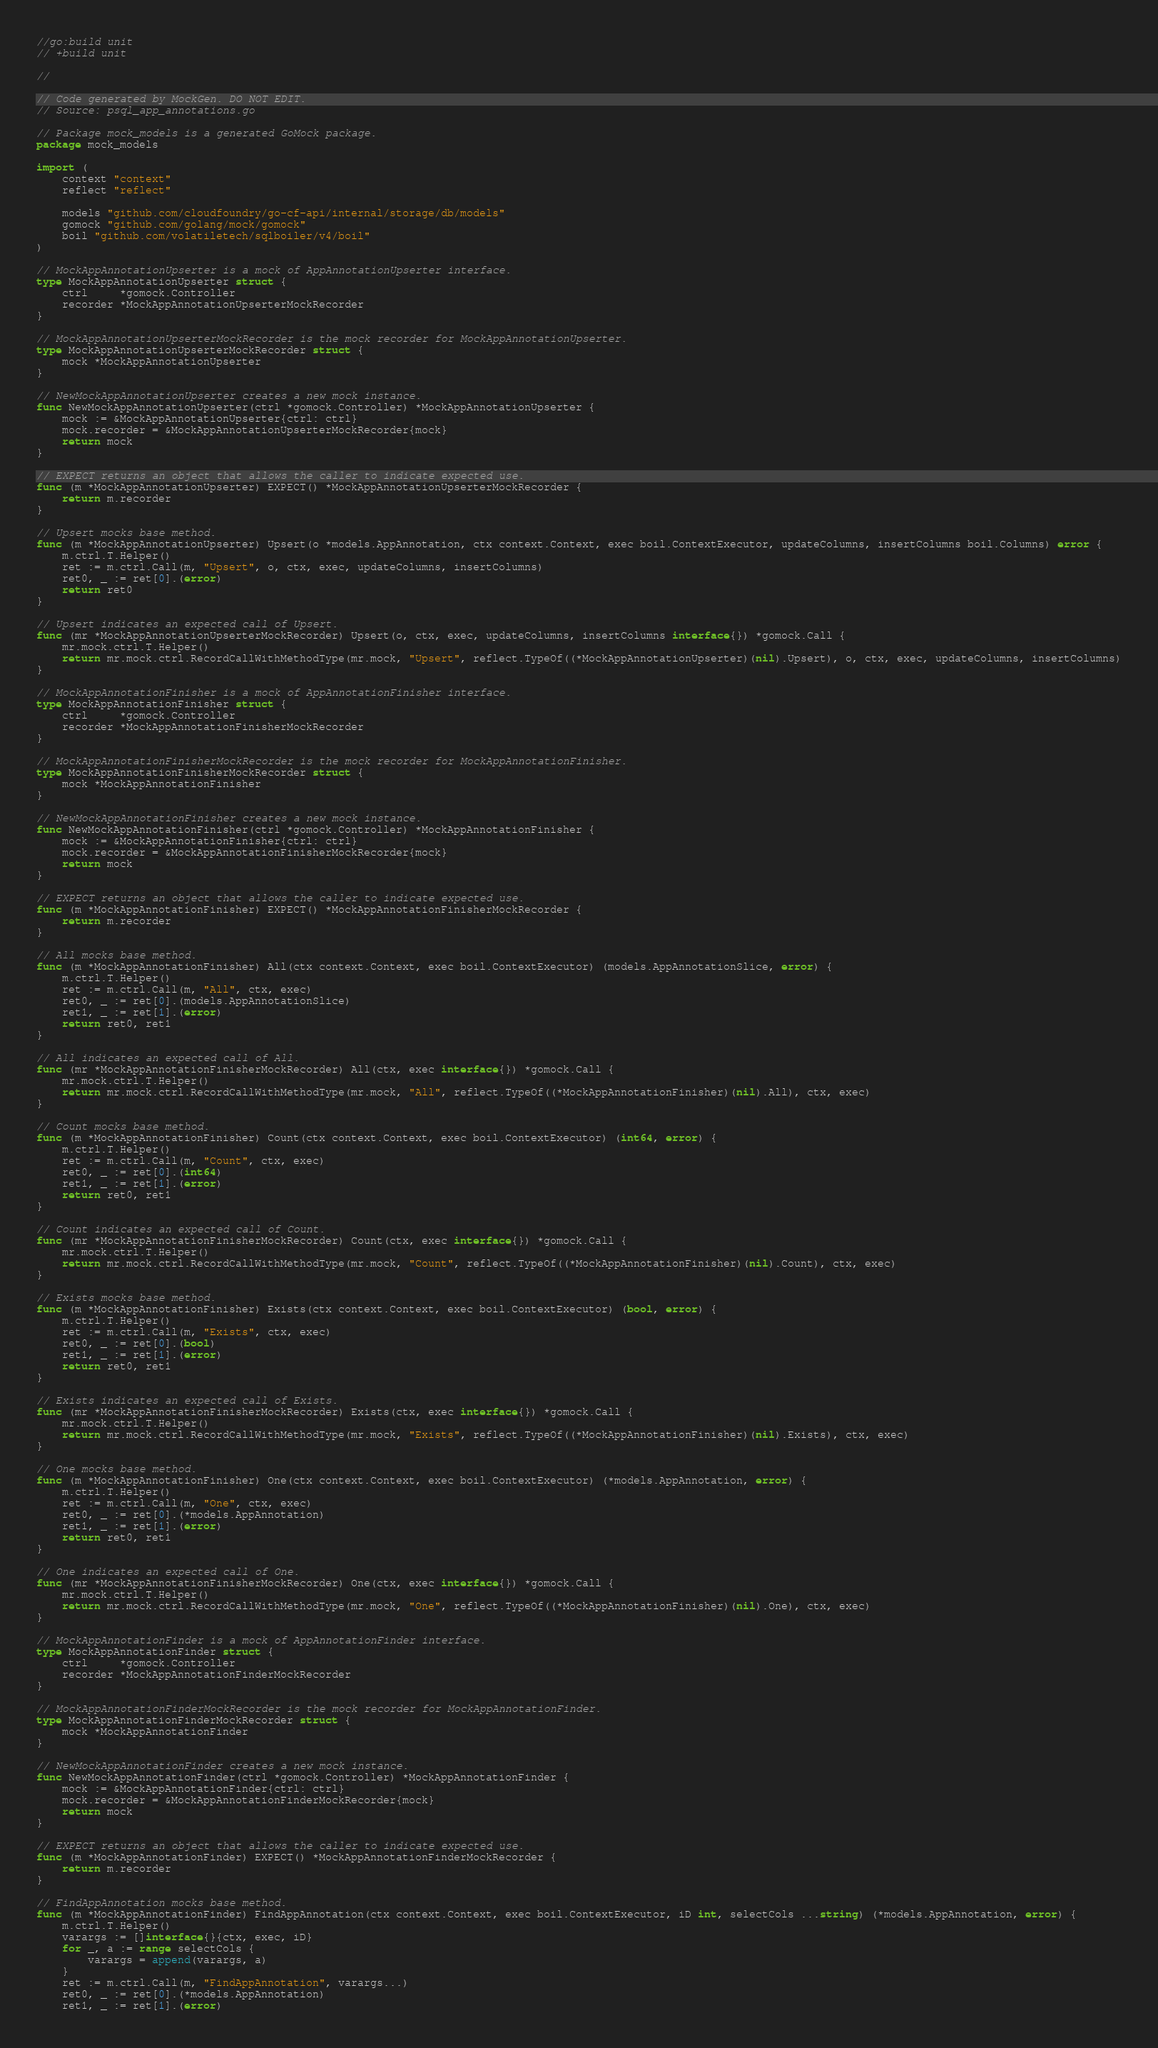Convert code to text. <code><loc_0><loc_0><loc_500><loc_500><_Go_>//go:build unit
// +build unit

//

// Code generated by MockGen. DO NOT EDIT.
// Source: psql_app_annotations.go

// Package mock_models is a generated GoMock package.
package mock_models

import (
	context "context"
	reflect "reflect"

	models "github.com/cloudfoundry/go-cf-api/internal/storage/db/models"
	gomock "github.com/golang/mock/gomock"
	boil "github.com/volatiletech/sqlboiler/v4/boil"
)

// MockAppAnnotationUpserter is a mock of AppAnnotationUpserter interface.
type MockAppAnnotationUpserter struct {
	ctrl     *gomock.Controller
	recorder *MockAppAnnotationUpserterMockRecorder
}

// MockAppAnnotationUpserterMockRecorder is the mock recorder for MockAppAnnotationUpserter.
type MockAppAnnotationUpserterMockRecorder struct {
	mock *MockAppAnnotationUpserter
}

// NewMockAppAnnotationUpserter creates a new mock instance.
func NewMockAppAnnotationUpserter(ctrl *gomock.Controller) *MockAppAnnotationUpserter {
	mock := &MockAppAnnotationUpserter{ctrl: ctrl}
	mock.recorder = &MockAppAnnotationUpserterMockRecorder{mock}
	return mock
}

// EXPECT returns an object that allows the caller to indicate expected use.
func (m *MockAppAnnotationUpserter) EXPECT() *MockAppAnnotationUpserterMockRecorder {
	return m.recorder
}

// Upsert mocks base method.
func (m *MockAppAnnotationUpserter) Upsert(o *models.AppAnnotation, ctx context.Context, exec boil.ContextExecutor, updateColumns, insertColumns boil.Columns) error {
	m.ctrl.T.Helper()
	ret := m.ctrl.Call(m, "Upsert", o, ctx, exec, updateColumns, insertColumns)
	ret0, _ := ret[0].(error)
	return ret0
}

// Upsert indicates an expected call of Upsert.
func (mr *MockAppAnnotationUpserterMockRecorder) Upsert(o, ctx, exec, updateColumns, insertColumns interface{}) *gomock.Call {
	mr.mock.ctrl.T.Helper()
	return mr.mock.ctrl.RecordCallWithMethodType(mr.mock, "Upsert", reflect.TypeOf((*MockAppAnnotationUpserter)(nil).Upsert), o, ctx, exec, updateColumns, insertColumns)
}

// MockAppAnnotationFinisher is a mock of AppAnnotationFinisher interface.
type MockAppAnnotationFinisher struct {
	ctrl     *gomock.Controller
	recorder *MockAppAnnotationFinisherMockRecorder
}

// MockAppAnnotationFinisherMockRecorder is the mock recorder for MockAppAnnotationFinisher.
type MockAppAnnotationFinisherMockRecorder struct {
	mock *MockAppAnnotationFinisher
}

// NewMockAppAnnotationFinisher creates a new mock instance.
func NewMockAppAnnotationFinisher(ctrl *gomock.Controller) *MockAppAnnotationFinisher {
	mock := &MockAppAnnotationFinisher{ctrl: ctrl}
	mock.recorder = &MockAppAnnotationFinisherMockRecorder{mock}
	return mock
}

// EXPECT returns an object that allows the caller to indicate expected use.
func (m *MockAppAnnotationFinisher) EXPECT() *MockAppAnnotationFinisherMockRecorder {
	return m.recorder
}

// All mocks base method.
func (m *MockAppAnnotationFinisher) All(ctx context.Context, exec boil.ContextExecutor) (models.AppAnnotationSlice, error) {
	m.ctrl.T.Helper()
	ret := m.ctrl.Call(m, "All", ctx, exec)
	ret0, _ := ret[0].(models.AppAnnotationSlice)
	ret1, _ := ret[1].(error)
	return ret0, ret1
}

// All indicates an expected call of All.
func (mr *MockAppAnnotationFinisherMockRecorder) All(ctx, exec interface{}) *gomock.Call {
	mr.mock.ctrl.T.Helper()
	return mr.mock.ctrl.RecordCallWithMethodType(mr.mock, "All", reflect.TypeOf((*MockAppAnnotationFinisher)(nil).All), ctx, exec)
}

// Count mocks base method.
func (m *MockAppAnnotationFinisher) Count(ctx context.Context, exec boil.ContextExecutor) (int64, error) {
	m.ctrl.T.Helper()
	ret := m.ctrl.Call(m, "Count", ctx, exec)
	ret0, _ := ret[0].(int64)
	ret1, _ := ret[1].(error)
	return ret0, ret1
}

// Count indicates an expected call of Count.
func (mr *MockAppAnnotationFinisherMockRecorder) Count(ctx, exec interface{}) *gomock.Call {
	mr.mock.ctrl.T.Helper()
	return mr.mock.ctrl.RecordCallWithMethodType(mr.mock, "Count", reflect.TypeOf((*MockAppAnnotationFinisher)(nil).Count), ctx, exec)
}

// Exists mocks base method.
func (m *MockAppAnnotationFinisher) Exists(ctx context.Context, exec boil.ContextExecutor) (bool, error) {
	m.ctrl.T.Helper()
	ret := m.ctrl.Call(m, "Exists", ctx, exec)
	ret0, _ := ret[0].(bool)
	ret1, _ := ret[1].(error)
	return ret0, ret1
}

// Exists indicates an expected call of Exists.
func (mr *MockAppAnnotationFinisherMockRecorder) Exists(ctx, exec interface{}) *gomock.Call {
	mr.mock.ctrl.T.Helper()
	return mr.mock.ctrl.RecordCallWithMethodType(mr.mock, "Exists", reflect.TypeOf((*MockAppAnnotationFinisher)(nil).Exists), ctx, exec)
}

// One mocks base method.
func (m *MockAppAnnotationFinisher) One(ctx context.Context, exec boil.ContextExecutor) (*models.AppAnnotation, error) {
	m.ctrl.T.Helper()
	ret := m.ctrl.Call(m, "One", ctx, exec)
	ret0, _ := ret[0].(*models.AppAnnotation)
	ret1, _ := ret[1].(error)
	return ret0, ret1
}

// One indicates an expected call of One.
func (mr *MockAppAnnotationFinisherMockRecorder) One(ctx, exec interface{}) *gomock.Call {
	mr.mock.ctrl.T.Helper()
	return mr.mock.ctrl.RecordCallWithMethodType(mr.mock, "One", reflect.TypeOf((*MockAppAnnotationFinisher)(nil).One), ctx, exec)
}

// MockAppAnnotationFinder is a mock of AppAnnotationFinder interface.
type MockAppAnnotationFinder struct {
	ctrl     *gomock.Controller
	recorder *MockAppAnnotationFinderMockRecorder
}

// MockAppAnnotationFinderMockRecorder is the mock recorder for MockAppAnnotationFinder.
type MockAppAnnotationFinderMockRecorder struct {
	mock *MockAppAnnotationFinder
}

// NewMockAppAnnotationFinder creates a new mock instance.
func NewMockAppAnnotationFinder(ctrl *gomock.Controller) *MockAppAnnotationFinder {
	mock := &MockAppAnnotationFinder{ctrl: ctrl}
	mock.recorder = &MockAppAnnotationFinderMockRecorder{mock}
	return mock
}

// EXPECT returns an object that allows the caller to indicate expected use.
func (m *MockAppAnnotationFinder) EXPECT() *MockAppAnnotationFinderMockRecorder {
	return m.recorder
}

// FindAppAnnotation mocks base method.
func (m *MockAppAnnotationFinder) FindAppAnnotation(ctx context.Context, exec boil.ContextExecutor, iD int, selectCols ...string) (*models.AppAnnotation, error) {
	m.ctrl.T.Helper()
	varargs := []interface{}{ctx, exec, iD}
	for _, a := range selectCols {
		varargs = append(varargs, a)
	}
	ret := m.ctrl.Call(m, "FindAppAnnotation", varargs...)
	ret0, _ := ret[0].(*models.AppAnnotation)
	ret1, _ := ret[1].(error)</code> 